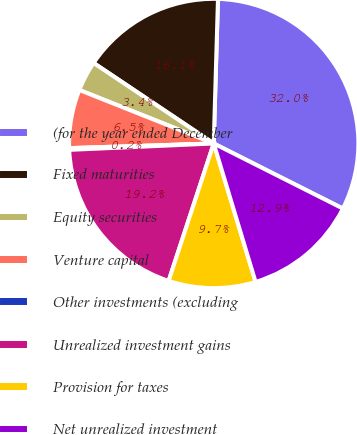Convert chart. <chart><loc_0><loc_0><loc_500><loc_500><pie_chart><fcel>(for the year ended December<fcel>Fixed maturities<fcel>Equity securities<fcel>Venture capital<fcel>Other investments (excluding<fcel>Unrealized investment gains<fcel>Provision for taxes<fcel>Net unrealized investment<nl><fcel>31.96%<fcel>16.07%<fcel>3.37%<fcel>6.54%<fcel>0.19%<fcel>19.25%<fcel>9.72%<fcel>12.9%<nl></chart> 